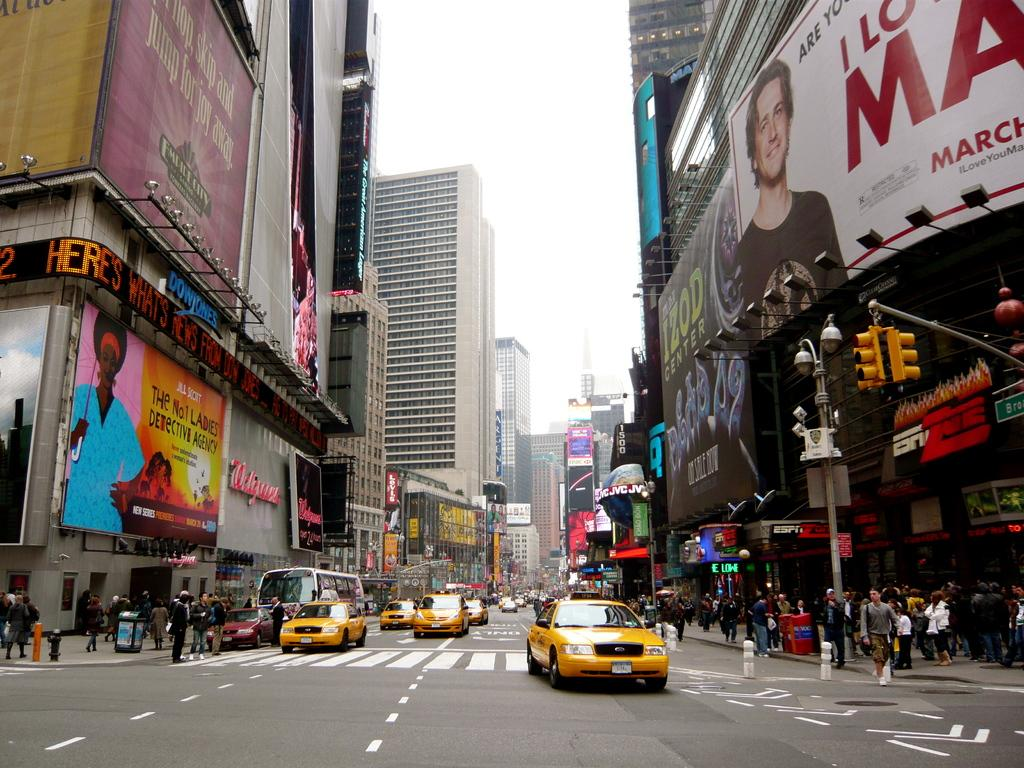<image>
Relay a brief, clear account of the picture shown. A busy city intersection has taxis and pedestrians beneath a sign that says Izod center. 